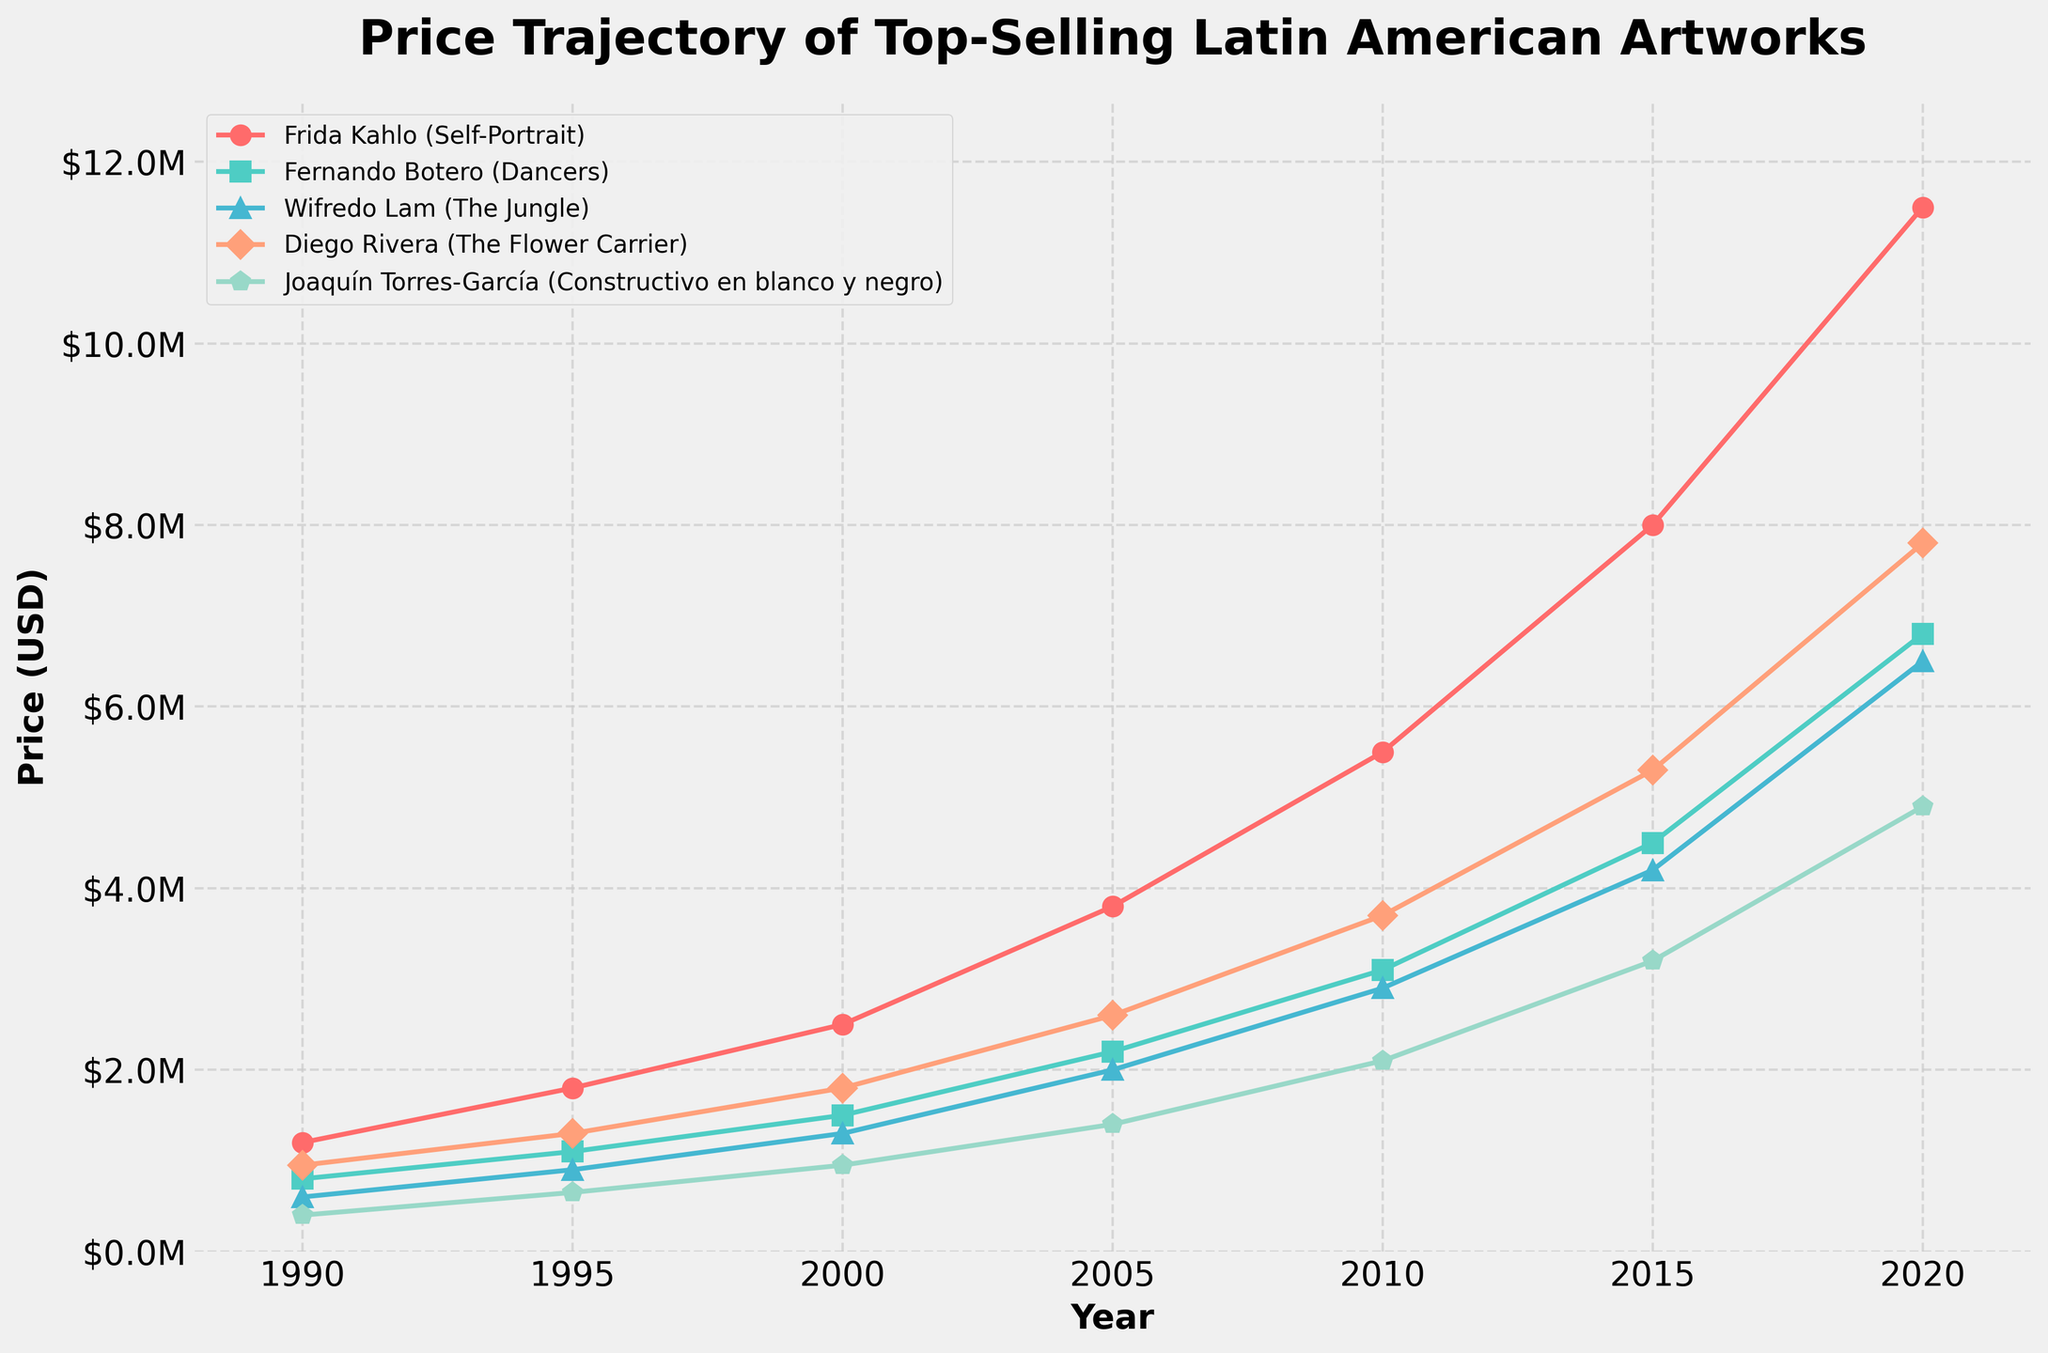In what year does Fernando Botero's artwork 'Dancers' first surpass the $1 million mark? We need to identify the year when the price for Fernando Botero's 'Dancers' exceeds $1 million. Looking at the line corresponding to Botero's 'Dancers', the price surpasses $1 million between 1990 and 1995. From the data, this happens in 1995.
Answer: 1995 Which artwork experiences the highest absolute increase in price from 2015 to 2020? We need to calculate the price difference for each artwork between 2015 and 2020 and determine the highest. Frida Kahlo's 'Self-Portrait' increases from $8,000,000 to $11,500,000 ($3,500,000 increase), Fernando Botero's 'Dancers' increase from $4,500,000 to $6,800,000 ($2,300,000 increase), Wifredo Lam's 'The Jungle' goes from $4,200,000 to $6,500,000 ($2,300,000 increase), Diego Rivera's 'The Flower Carrier' rises from $5,300,000 to $7,800,000 ($2,500,000 increase), and Joaquín Torres-García's 'Constructivo en blanco y negro' rises from $3,200,000 to $4,900,000 ($1,700,000 increase). The highest increase is for Frida Kahlo's 'Self-Portrait'.
Answer: Frida Kahlo's 'Self-Portrait' What is the price ratio between Diego Rivera's 'The Flower Carrier' and Joaquín Torres-García's 'Constructivo en blanco y negro' in 2005? To find the price ratio, we divide Diego Rivera's 2005 price by Joaquín Torres-García's 2005 price. From the data, the prices are $2,600,000 and $1,400,000 respectively. The ratio is ($2,600,000 / $1,400,000) = 1.857.
Answer: 1.857 What was the average price of Frida Kahlo's 'Self-Portrait' between 1990 and 2020? We need to calculate the average price of Frida Kahlo's 'Self-Portrait'. Summing up the prices from 1990 to 2020 ($1,200,000 + $1,800,000 + $2,500,000 + $3,800,000 + $5,500,000 + $8,000,000 + $11,500,000) gives $34,300,000. Dividing by 7 (number of data points) results in an average price of $4,900,000.
Answer: $4,900,000 Which artwork had the lowest price in 1990, and what was that price? From the data for 1990, we compare all the given prices: Frida Kahlo's 'Self-Portrait' at $1,200,000, Fernando Botero's 'Dancers' at $800,000, Wifredo Lam's 'The Jungle' at $600,000, Diego Rivera's 'The Flower Carrier' at $950,000, and Joaquín Torres-García's 'Constructivo en blanco y negro' at $400,000. The lowest price is Joaquín Torres-García's 'Constructivo en blanco y negro' with $400,000.
Answer: Joaquín Torres-García's 'Constructivo en blanco y negro', $400,000 By what percentage did the price of Wifredo Lam's 'The Jungle' increase from 1990 to 2000? To find the percentage increase, we first calculate the difference between the prices in 2000 and 1990 ($1,300,000 - $600,000 = $700,000). Then, divide the difference by the 1990 price and multiply by 100: ($700,000 / $600,000) * 100 = 116.67%.
Answer: 116.67% Which artist's work showed the most consistent price growth over the 30 years? To determine consistent growth, we look at the trajectory/slope of each artwork's line over the years. Visually inspecting the plot, Frida Kahlo's 'Self-Portrait' demonstrates a smooth, steady increase without any erratic jumps or dips, suggesting the most consistent growth.
Answer: Frida Kahlo 